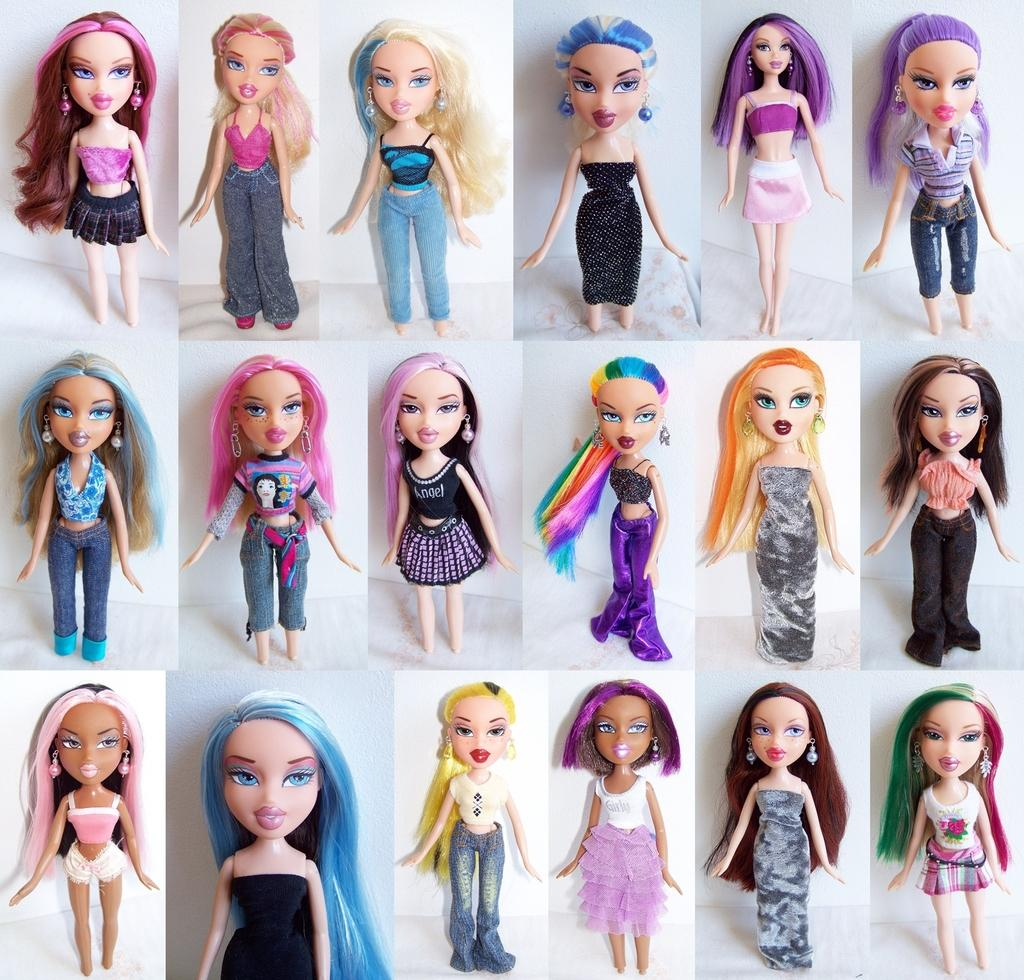What type of image is being described? The image is a collage. What is the subject matter of the collage? The collage consists of Barbie toys. How are the Barbie toys dressed in the collage? The Barbie toys are in different dresses. What type of coat is the Barbie wearing in the image? There is no coat present in the image, as the Barbie toys are dressed in different dresses. 